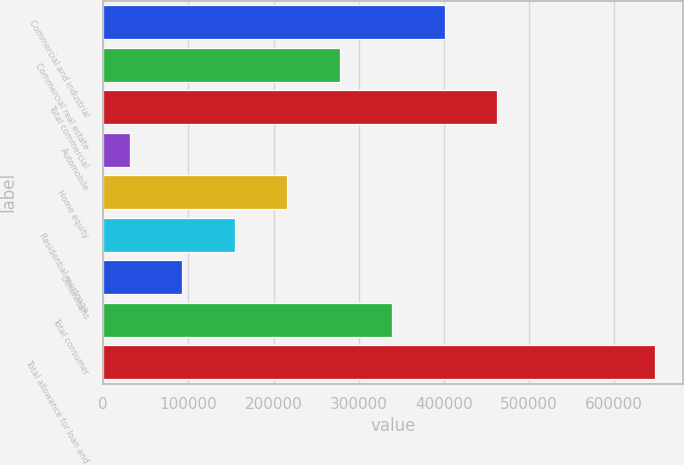<chart> <loc_0><loc_0><loc_500><loc_500><bar_chart><fcel>Commercial and industrial<fcel>Commercial real estate<fcel>Total commercial<fcel>Automobile<fcel>Home equity<fcel>Residential mortgage<fcel>Other loans<fcel>Total consumer<fcel>Total allowance for loan and<nl><fcel>401143<fcel>277780<fcel>462825<fcel>31053<fcel>216098<fcel>154416<fcel>92734.7<fcel>339462<fcel>647870<nl></chart> 